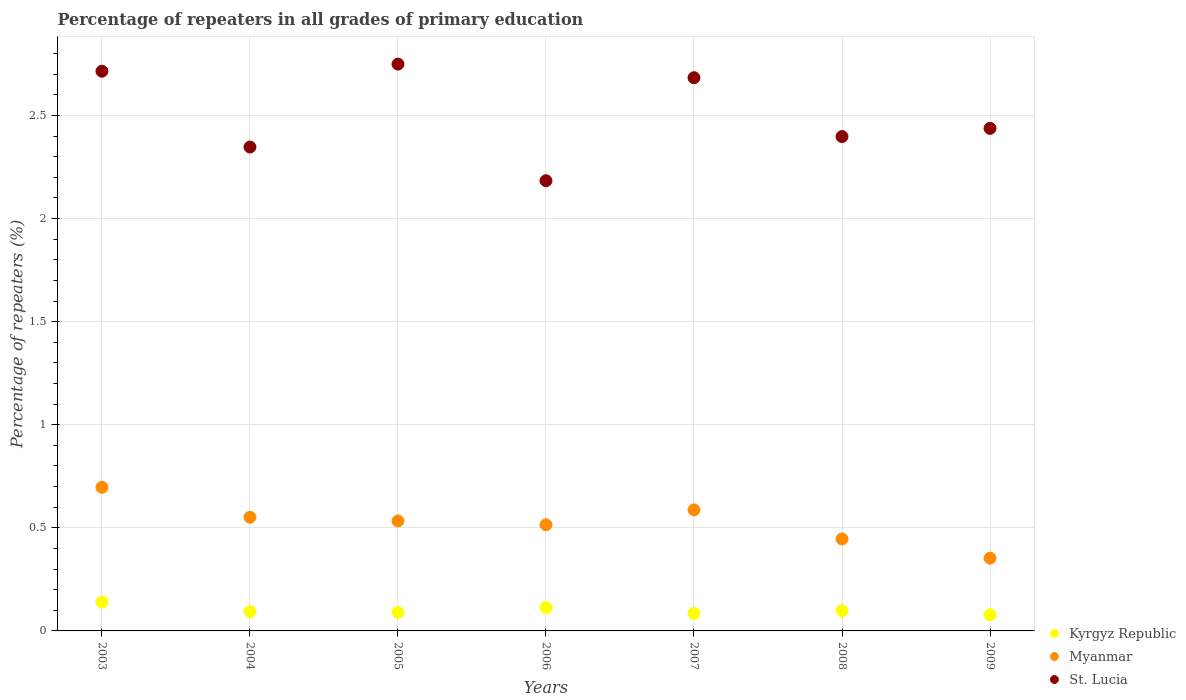What is the percentage of repeaters in St. Lucia in 2008?
Offer a very short reply. 2.4. Across all years, what is the maximum percentage of repeaters in St. Lucia?
Ensure brevity in your answer.  2.75. Across all years, what is the minimum percentage of repeaters in St. Lucia?
Offer a terse response. 2.18. In which year was the percentage of repeaters in St. Lucia maximum?
Make the answer very short. 2005. In which year was the percentage of repeaters in St. Lucia minimum?
Provide a succinct answer. 2006. What is the total percentage of repeaters in Kyrgyz Republic in the graph?
Your answer should be very brief. 0.7. What is the difference between the percentage of repeaters in St. Lucia in 2005 and that in 2006?
Your answer should be compact. 0.57. What is the difference between the percentage of repeaters in Kyrgyz Republic in 2006 and the percentage of repeaters in St. Lucia in 2009?
Give a very brief answer. -2.32. What is the average percentage of repeaters in Kyrgyz Republic per year?
Keep it short and to the point. 0.1. In the year 2008, what is the difference between the percentage of repeaters in St. Lucia and percentage of repeaters in Myanmar?
Your answer should be compact. 1.95. What is the ratio of the percentage of repeaters in St. Lucia in 2008 to that in 2009?
Your answer should be compact. 0.98. Is the percentage of repeaters in Myanmar in 2003 less than that in 2005?
Ensure brevity in your answer.  No. Is the difference between the percentage of repeaters in St. Lucia in 2004 and 2008 greater than the difference between the percentage of repeaters in Myanmar in 2004 and 2008?
Your response must be concise. No. What is the difference between the highest and the second highest percentage of repeaters in Kyrgyz Republic?
Give a very brief answer. 0.03. What is the difference between the highest and the lowest percentage of repeaters in St. Lucia?
Your answer should be very brief. 0.57. Is the sum of the percentage of repeaters in Kyrgyz Republic in 2006 and 2008 greater than the maximum percentage of repeaters in Myanmar across all years?
Your answer should be compact. No. Does the percentage of repeaters in Myanmar monotonically increase over the years?
Keep it short and to the point. No. Is the percentage of repeaters in Myanmar strictly greater than the percentage of repeaters in Kyrgyz Republic over the years?
Keep it short and to the point. Yes. How many dotlines are there?
Provide a short and direct response. 3. How many years are there in the graph?
Keep it short and to the point. 7. What is the difference between two consecutive major ticks on the Y-axis?
Keep it short and to the point. 0.5. Does the graph contain grids?
Ensure brevity in your answer.  Yes. What is the title of the graph?
Ensure brevity in your answer.  Percentage of repeaters in all grades of primary education. What is the label or title of the X-axis?
Your response must be concise. Years. What is the label or title of the Y-axis?
Keep it short and to the point. Percentage of repeaters (%). What is the Percentage of repeaters (%) of Kyrgyz Republic in 2003?
Your answer should be very brief. 0.14. What is the Percentage of repeaters (%) of Myanmar in 2003?
Offer a very short reply. 0.7. What is the Percentage of repeaters (%) of St. Lucia in 2003?
Make the answer very short. 2.71. What is the Percentage of repeaters (%) in Kyrgyz Republic in 2004?
Keep it short and to the point. 0.09. What is the Percentage of repeaters (%) in Myanmar in 2004?
Keep it short and to the point. 0.55. What is the Percentage of repeaters (%) in St. Lucia in 2004?
Offer a terse response. 2.35. What is the Percentage of repeaters (%) of Kyrgyz Republic in 2005?
Make the answer very short. 0.09. What is the Percentage of repeaters (%) of Myanmar in 2005?
Your answer should be very brief. 0.53. What is the Percentage of repeaters (%) of St. Lucia in 2005?
Ensure brevity in your answer.  2.75. What is the Percentage of repeaters (%) of Kyrgyz Republic in 2006?
Offer a terse response. 0.11. What is the Percentage of repeaters (%) of Myanmar in 2006?
Give a very brief answer. 0.51. What is the Percentage of repeaters (%) of St. Lucia in 2006?
Keep it short and to the point. 2.18. What is the Percentage of repeaters (%) in Kyrgyz Republic in 2007?
Make the answer very short. 0.08. What is the Percentage of repeaters (%) of Myanmar in 2007?
Offer a terse response. 0.59. What is the Percentage of repeaters (%) of St. Lucia in 2007?
Your answer should be compact. 2.68. What is the Percentage of repeaters (%) of Kyrgyz Republic in 2008?
Give a very brief answer. 0.1. What is the Percentage of repeaters (%) of Myanmar in 2008?
Your answer should be very brief. 0.45. What is the Percentage of repeaters (%) in St. Lucia in 2008?
Your answer should be compact. 2.4. What is the Percentage of repeaters (%) of Kyrgyz Republic in 2009?
Your answer should be very brief. 0.08. What is the Percentage of repeaters (%) of Myanmar in 2009?
Your answer should be compact. 0.35. What is the Percentage of repeaters (%) of St. Lucia in 2009?
Provide a short and direct response. 2.44. Across all years, what is the maximum Percentage of repeaters (%) of Kyrgyz Republic?
Your answer should be very brief. 0.14. Across all years, what is the maximum Percentage of repeaters (%) of Myanmar?
Make the answer very short. 0.7. Across all years, what is the maximum Percentage of repeaters (%) of St. Lucia?
Offer a terse response. 2.75. Across all years, what is the minimum Percentage of repeaters (%) of Kyrgyz Republic?
Make the answer very short. 0.08. Across all years, what is the minimum Percentage of repeaters (%) in Myanmar?
Provide a succinct answer. 0.35. Across all years, what is the minimum Percentage of repeaters (%) in St. Lucia?
Provide a short and direct response. 2.18. What is the total Percentage of repeaters (%) of Kyrgyz Republic in the graph?
Make the answer very short. 0.7. What is the total Percentage of repeaters (%) in Myanmar in the graph?
Your answer should be compact. 3.68. What is the total Percentage of repeaters (%) in St. Lucia in the graph?
Keep it short and to the point. 17.51. What is the difference between the Percentage of repeaters (%) in Kyrgyz Republic in 2003 and that in 2004?
Your answer should be very brief. 0.05. What is the difference between the Percentage of repeaters (%) in Myanmar in 2003 and that in 2004?
Your response must be concise. 0.15. What is the difference between the Percentage of repeaters (%) in St. Lucia in 2003 and that in 2004?
Your answer should be very brief. 0.37. What is the difference between the Percentage of repeaters (%) in Kyrgyz Republic in 2003 and that in 2005?
Your response must be concise. 0.05. What is the difference between the Percentage of repeaters (%) in Myanmar in 2003 and that in 2005?
Provide a short and direct response. 0.16. What is the difference between the Percentage of repeaters (%) in St. Lucia in 2003 and that in 2005?
Provide a short and direct response. -0.03. What is the difference between the Percentage of repeaters (%) in Kyrgyz Republic in 2003 and that in 2006?
Your answer should be very brief. 0.03. What is the difference between the Percentage of repeaters (%) of Myanmar in 2003 and that in 2006?
Your answer should be very brief. 0.18. What is the difference between the Percentage of repeaters (%) of St. Lucia in 2003 and that in 2006?
Offer a terse response. 0.53. What is the difference between the Percentage of repeaters (%) of Kyrgyz Republic in 2003 and that in 2007?
Offer a very short reply. 0.05. What is the difference between the Percentage of repeaters (%) of Myanmar in 2003 and that in 2007?
Your response must be concise. 0.11. What is the difference between the Percentage of repeaters (%) in St. Lucia in 2003 and that in 2007?
Your response must be concise. 0.03. What is the difference between the Percentage of repeaters (%) in Kyrgyz Republic in 2003 and that in 2008?
Give a very brief answer. 0.04. What is the difference between the Percentage of repeaters (%) of Myanmar in 2003 and that in 2008?
Make the answer very short. 0.25. What is the difference between the Percentage of repeaters (%) of St. Lucia in 2003 and that in 2008?
Provide a short and direct response. 0.32. What is the difference between the Percentage of repeaters (%) in Kyrgyz Republic in 2003 and that in 2009?
Provide a short and direct response. 0.06. What is the difference between the Percentage of repeaters (%) in Myanmar in 2003 and that in 2009?
Offer a terse response. 0.34. What is the difference between the Percentage of repeaters (%) of St. Lucia in 2003 and that in 2009?
Your answer should be very brief. 0.28. What is the difference between the Percentage of repeaters (%) of Kyrgyz Republic in 2004 and that in 2005?
Offer a very short reply. 0. What is the difference between the Percentage of repeaters (%) of Myanmar in 2004 and that in 2005?
Your response must be concise. 0.02. What is the difference between the Percentage of repeaters (%) in St. Lucia in 2004 and that in 2005?
Give a very brief answer. -0.4. What is the difference between the Percentage of repeaters (%) in Kyrgyz Republic in 2004 and that in 2006?
Your response must be concise. -0.02. What is the difference between the Percentage of repeaters (%) in Myanmar in 2004 and that in 2006?
Your answer should be very brief. 0.04. What is the difference between the Percentage of repeaters (%) of St. Lucia in 2004 and that in 2006?
Keep it short and to the point. 0.16. What is the difference between the Percentage of repeaters (%) in Kyrgyz Republic in 2004 and that in 2007?
Offer a very short reply. 0.01. What is the difference between the Percentage of repeaters (%) in Myanmar in 2004 and that in 2007?
Provide a short and direct response. -0.04. What is the difference between the Percentage of repeaters (%) of St. Lucia in 2004 and that in 2007?
Ensure brevity in your answer.  -0.34. What is the difference between the Percentage of repeaters (%) of Kyrgyz Republic in 2004 and that in 2008?
Your response must be concise. -0. What is the difference between the Percentage of repeaters (%) in Myanmar in 2004 and that in 2008?
Your answer should be compact. 0.11. What is the difference between the Percentage of repeaters (%) of St. Lucia in 2004 and that in 2008?
Ensure brevity in your answer.  -0.05. What is the difference between the Percentage of repeaters (%) in Kyrgyz Republic in 2004 and that in 2009?
Provide a succinct answer. 0.02. What is the difference between the Percentage of repeaters (%) in Myanmar in 2004 and that in 2009?
Offer a very short reply. 0.2. What is the difference between the Percentage of repeaters (%) in St. Lucia in 2004 and that in 2009?
Ensure brevity in your answer.  -0.09. What is the difference between the Percentage of repeaters (%) of Kyrgyz Republic in 2005 and that in 2006?
Your response must be concise. -0.02. What is the difference between the Percentage of repeaters (%) in Myanmar in 2005 and that in 2006?
Give a very brief answer. 0.02. What is the difference between the Percentage of repeaters (%) of St. Lucia in 2005 and that in 2006?
Your response must be concise. 0.57. What is the difference between the Percentage of repeaters (%) in Kyrgyz Republic in 2005 and that in 2007?
Provide a short and direct response. 0.01. What is the difference between the Percentage of repeaters (%) in Myanmar in 2005 and that in 2007?
Give a very brief answer. -0.05. What is the difference between the Percentage of repeaters (%) in St. Lucia in 2005 and that in 2007?
Provide a short and direct response. 0.07. What is the difference between the Percentage of repeaters (%) of Kyrgyz Republic in 2005 and that in 2008?
Provide a succinct answer. -0.01. What is the difference between the Percentage of repeaters (%) in Myanmar in 2005 and that in 2008?
Give a very brief answer. 0.09. What is the difference between the Percentage of repeaters (%) in St. Lucia in 2005 and that in 2008?
Provide a succinct answer. 0.35. What is the difference between the Percentage of repeaters (%) in Kyrgyz Republic in 2005 and that in 2009?
Your answer should be compact. 0.01. What is the difference between the Percentage of repeaters (%) of Myanmar in 2005 and that in 2009?
Keep it short and to the point. 0.18. What is the difference between the Percentage of repeaters (%) of St. Lucia in 2005 and that in 2009?
Offer a terse response. 0.31. What is the difference between the Percentage of repeaters (%) in Kyrgyz Republic in 2006 and that in 2007?
Provide a succinct answer. 0.03. What is the difference between the Percentage of repeaters (%) of Myanmar in 2006 and that in 2007?
Give a very brief answer. -0.07. What is the difference between the Percentage of repeaters (%) of St. Lucia in 2006 and that in 2007?
Give a very brief answer. -0.5. What is the difference between the Percentage of repeaters (%) in Kyrgyz Republic in 2006 and that in 2008?
Your answer should be compact. 0.02. What is the difference between the Percentage of repeaters (%) in Myanmar in 2006 and that in 2008?
Keep it short and to the point. 0.07. What is the difference between the Percentage of repeaters (%) of St. Lucia in 2006 and that in 2008?
Keep it short and to the point. -0.21. What is the difference between the Percentage of repeaters (%) of Kyrgyz Republic in 2006 and that in 2009?
Offer a very short reply. 0.03. What is the difference between the Percentage of repeaters (%) of Myanmar in 2006 and that in 2009?
Offer a terse response. 0.16. What is the difference between the Percentage of repeaters (%) in St. Lucia in 2006 and that in 2009?
Make the answer very short. -0.25. What is the difference between the Percentage of repeaters (%) in Kyrgyz Republic in 2007 and that in 2008?
Provide a succinct answer. -0.01. What is the difference between the Percentage of repeaters (%) of Myanmar in 2007 and that in 2008?
Your answer should be compact. 0.14. What is the difference between the Percentage of repeaters (%) of St. Lucia in 2007 and that in 2008?
Ensure brevity in your answer.  0.29. What is the difference between the Percentage of repeaters (%) in Kyrgyz Republic in 2007 and that in 2009?
Your answer should be very brief. 0.01. What is the difference between the Percentage of repeaters (%) in Myanmar in 2007 and that in 2009?
Offer a terse response. 0.23. What is the difference between the Percentage of repeaters (%) of St. Lucia in 2007 and that in 2009?
Provide a short and direct response. 0.25. What is the difference between the Percentage of repeaters (%) of Kyrgyz Republic in 2008 and that in 2009?
Offer a terse response. 0.02. What is the difference between the Percentage of repeaters (%) of Myanmar in 2008 and that in 2009?
Offer a very short reply. 0.09. What is the difference between the Percentage of repeaters (%) of St. Lucia in 2008 and that in 2009?
Provide a short and direct response. -0.04. What is the difference between the Percentage of repeaters (%) in Kyrgyz Republic in 2003 and the Percentage of repeaters (%) in Myanmar in 2004?
Give a very brief answer. -0.41. What is the difference between the Percentage of repeaters (%) in Kyrgyz Republic in 2003 and the Percentage of repeaters (%) in St. Lucia in 2004?
Provide a succinct answer. -2.21. What is the difference between the Percentage of repeaters (%) of Myanmar in 2003 and the Percentage of repeaters (%) of St. Lucia in 2004?
Offer a terse response. -1.65. What is the difference between the Percentage of repeaters (%) in Kyrgyz Republic in 2003 and the Percentage of repeaters (%) in Myanmar in 2005?
Your answer should be very brief. -0.39. What is the difference between the Percentage of repeaters (%) of Kyrgyz Republic in 2003 and the Percentage of repeaters (%) of St. Lucia in 2005?
Your answer should be compact. -2.61. What is the difference between the Percentage of repeaters (%) in Myanmar in 2003 and the Percentage of repeaters (%) in St. Lucia in 2005?
Keep it short and to the point. -2.05. What is the difference between the Percentage of repeaters (%) of Kyrgyz Republic in 2003 and the Percentage of repeaters (%) of Myanmar in 2006?
Provide a succinct answer. -0.38. What is the difference between the Percentage of repeaters (%) of Kyrgyz Republic in 2003 and the Percentage of repeaters (%) of St. Lucia in 2006?
Provide a succinct answer. -2.04. What is the difference between the Percentage of repeaters (%) of Myanmar in 2003 and the Percentage of repeaters (%) of St. Lucia in 2006?
Give a very brief answer. -1.49. What is the difference between the Percentage of repeaters (%) in Kyrgyz Republic in 2003 and the Percentage of repeaters (%) in Myanmar in 2007?
Make the answer very short. -0.45. What is the difference between the Percentage of repeaters (%) in Kyrgyz Republic in 2003 and the Percentage of repeaters (%) in St. Lucia in 2007?
Offer a very short reply. -2.54. What is the difference between the Percentage of repeaters (%) of Myanmar in 2003 and the Percentage of repeaters (%) of St. Lucia in 2007?
Give a very brief answer. -1.99. What is the difference between the Percentage of repeaters (%) in Kyrgyz Republic in 2003 and the Percentage of repeaters (%) in Myanmar in 2008?
Keep it short and to the point. -0.31. What is the difference between the Percentage of repeaters (%) of Kyrgyz Republic in 2003 and the Percentage of repeaters (%) of St. Lucia in 2008?
Make the answer very short. -2.26. What is the difference between the Percentage of repeaters (%) of Myanmar in 2003 and the Percentage of repeaters (%) of St. Lucia in 2008?
Provide a short and direct response. -1.7. What is the difference between the Percentage of repeaters (%) of Kyrgyz Republic in 2003 and the Percentage of repeaters (%) of Myanmar in 2009?
Provide a succinct answer. -0.21. What is the difference between the Percentage of repeaters (%) of Kyrgyz Republic in 2003 and the Percentage of repeaters (%) of St. Lucia in 2009?
Your answer should be compact. -2.3. What is the difference between the Percentage of repeaters (%) of Myanmar in 2003 and the Percentage of repeaters (%) of St. Lucia in 2009?
Your response must be concise. -1.74. What is the difference between the Percentage of repeaters (%) of Kyrgyz Republic in 2004 and the Percentage of repeaters (%) of Myanmar in 2005?
Make the answer very short. -0.44. What is the difference between the Percentage of repeaters (%) of Kyrgyz Republic in 2004 and the Percentage of repeaters (%) of St. Lucia in 2005?
Offer a terse response. -2.66. What is the difference between the Percentage of repeaters (%) in Myanmar in 2004 and the Percentage of repeaters (%) in St. Lucia in 2005?
Provide a succinct answer. -2.2. What is the difference between the Percentage of repeaters (%) of Kyrgyz Republic in 2004 and the Percentage of repeaters (%) of Myanmar in 2006?
Make the answer very short. -0.42. What is the difference between the Percentage of repeaters (%) in Kyrgyz Republic in 2004 and the Percentage of repeaters (%) in St. Lucia in 2006?
Keep it short and to the point. -2.09. What is the difference between the Percentage of repeaters (%) of Myanmar in 2004 and the Percentage of repeaters (%) of St. Lucia in 2006?
Keep it short and to the point. -1.63. What is the difference between the Percentage of repeaters (%) of Kyrgyz Republic in 2004 and the Percentage of repeaters (%) of Myanmar in 2007?
Make the answer very short. -0.49. What is the difference between the Percentage of repeaters (%) in Kyrgyz Republic in 2004 and the Percentage of repeaters (%) in St. Lucia in 2007?
Provide a succinct answer. -2.59. What is the difference between the Percentage of repeaters (%) in Myanmar in 2004 and the Percentage of repeaters (%) in St. Lucia in 2007?
Your answer should be compact. -2.13. What is the difference between the Percentage of repeaters (%) of Kyrgyz Republic in 2004 and the Percentage of repeaters (%) of Myanmar in 2008?
Give a very brief answer. -0.35. What is the difference between the Percentage of repeaters (%) in Kyrgyz Republic in 2004 and the Percentage of repeaters (%) in St. Lucia in 2008?
Your answer should be very brief. -2.3. What is the difference between the Percentage of repeaters (%) of Myanmar in 2004 and the Percentage of repeaters (%) of St. Lucia in 2008?
Keep it short and to the point. -1.85. What is the difference between the Percentage of repeaters (%) in Kyrgyz Republic in 2004 and the Percentage of repeaters (%) in Myanmar in 2009?
Make the answer very short. -0.26. What is the difference between the Percentage of repeaters (%) in Kyrgyz Republic in 2004 and the Percentage of repeaters (%) in St. Lucia in 2009?
Provide a succinct answer. -2.34. What is the difference between the Percentage of repeaters (%) in Myanmar in 2004 and the Percentage of repeaters (%) in St. Lucia in 2009?
Offer a very short reply. -1.89. What is the difference between the Percentage of repeaters (%) of Kyrgyz Republic in 2005 and the Percentage of repeaters (%) of Myanmar in 2006?
Your answer should be compact. -0.43. What is the difference between the Percentage of repeaters (%) in Kyrgyz Republic in 2005 and the Percentage of repeaters (%) in St. Lucia in 2006?
Keep it short and to the point. -2.09. What is the difference between the Percentage of repeaters (%) of Myanmar in 2005 and the Percentage of repeaters (%) of St. Lucia in 2006?
Make the answer very short. -1.65. What is the difference between the Percentage of repeaters (%) of Kyrgyz Republic in 2005 and the Percentage of repeaters (%) of Myanmar in 2007?
Your answer should be compact. -0.5. What is the difference between the Percentage of repeaters (%) of Kyrgyz Republic in 2005 and the Percentage of repeaters (%) of St. Lucia in 2007?
Ensure brevity in your answer.  -2.59. What is the difference between the Percentage of repeaters (%) in Myanmar in 2005 and the Percentage of repeaters (%) in St. Lucia in 2007?
Make the answer very short. -2.15. What is the difference between the Percentage of repeaters (%) in Kyrgyz Republic in 2005 and the Percentage of repeaters (%) in Myanmar in 2008?
Your response must be concise. -0.36. What is the difference between the Percentage of repeaters (%) of Kyrgyz Republic in 2005 and the Percentage of repeaters (%) of St. Lucia in 2008?
Offer a terse response. -2.31. What is the difference between the Percentage of repeaters (%) in Myanmar in 2005 and the Percentage of repeaters (%) in St. Lucia in 2008?
Provide a succinct answer. -1.86. What is the difference between the Percentage of repeaters (%) in Kyrgyz Republic in 2005 and the Percentage of repeaters (%) in Myanmar in 2009?
Make the answer very short. -0.26. What is the difference between the Percentage of repeaters (%) of Kyrgyz Republic in 2005 and the Percentage of repeaters (%) of St. Lucia in 2009?
Your answer should be very brief. -2.35. What is the difference between the Percentage of repeaters (%) of Myanmar in 2005 and the Percentage of repeaters (%) of St. Lucia in 2009?
Provide a succinct answer. -1.9. What is the difference between the Percentage of repeaters (%) of Kyrgyz Republic in 2006 and the Percentage of repeaters (%) of Myanmar in 2007?
Your answer should be very brief. -0.47. What is the difference between the Percentage of repeaters (%) in Kyrgyz Republic in 2006 and the Percentage of repeaters (%) in St. Lucia in 2007?
Provide a short and direct response. -2.57. What is the difference between the Percentage of repeaters (%) in Myanmar in 2006 and the Percentage of repeaters (%) in St. Lucia in 2007?
Provide a succinct answer. -2.17. What is the difference between the Percentage of repeaters (%) of Kyrgyz Republic in 2006 and the Percentage of repeaters (%) of Myanmar in 2008?
Provide a succinct answer. -0.33. What is the difference between the Percentage of repeaters (%) in Kyrgyz Republic in 2006 and the Percentage of repeaters (%) in St. Lucia in 2008?
Provide a short and direct response. -2.28. What is the difference between the Percentage of repeaters (%) in Myanmar in 2006 and the Percentage of repeaters (%) in St. Lucia in 2008?
Keep it short and to the point. -1.88. What is the difference between the Percentage of repeaters (%) in Kyrgyz Republic in 2006 and the Percentage of repeaters (%) in Myanmar in 2009?
Ensure brevity in your answer.  -0.24. What is the difference between the Percentage of repeaters (%) of Kyrgyz Republic in 2006 and the Percentage of repeaters (%) of St. Lucia in 2009?
Your answer should be very brief. -2.32. What is the difference between the Percentage of repeaters (%) in Myanmar in 2006 and the Percentage of repeaters (%) in St. Lucia in 2009?
Give a very brief answer. -1.92. What is the difference between the Percentage of repeaters (%) in Kyrgyz Republic in 2007 and the Percentage of repeaters (%) in Myanmar in 2008?
Provide a short and direct response. -0.36. What is the difference between the Percentage of repeaters (%) of Kyrgyz Republic in 2007 and the Percentage of repeaters (%) of St. Lucia in 2008?
Ensure brevity in your answer.  -2.31. What is the difference between the Percentage of repeaters (%) in Myanmar in 2007 and the Percentage of repeaters (%) in St. Lucia in 2008?
Provide a succinct answer. -1.81. What is the difference between the Percentage of repeaters (%) of Kyrgyz Republic in 2007 and the Percentage of repeaters (%) of Myanmar in 2009?
Keep it short and to the point. -0.27. What is the difference between the Percentage of repeaters (%) in Kyrgyz Republic in 2007 and the Percentage of repeaters (%) in St. Lucia in 2009?
Make the answer very short. -2.35. What is the difference between the Percentage of repeaters (%) in Myanmar in 2007 and the Percentage of repeaters (%) in St. Lucia in 2009?
Your response must be concise. -1.85. What is the difference between the Percentage of repeaters (%) in Kyrgyz Republic in 2008 and the Percentage of repeaters (%) in Myanmar in 2009?
Your answer should be compact. -0.26. What is the difference between the Percentage of repeaters (%) of Kyrgyz Republic in 2008 and the Percentage of repeaters (%) of St. Lucia in 2009?
Give a very brief answer. -2.34. What is the difference between the Percentage of repeaters (%) in Myanmar in 2008 and the Percentage of repeaters (%) in St. Lucia in 2009?
Your response must be concise. -1.99. What is the average Percentage of repeaters (%) in Kyrgyz Republic per year?
Provide a short and direct response. 0.1. What is the average Percentage of repeaters (%) of Myanmar per year?
Provide a short and direct response. 0.53. What is the average Percentage of repeaters (%) of St. Lucia per year?
Your answer should be compact. 2.5. In the year 2003, what is the difference between the Percentage of repeaters (%) of Kyrgyz Republic and Percentage of repeaters (%) of Myanmar?
Keep it short and to the point. -0.56. In the year 2003, what is the difference between the Percentage of repeaters (%) in Kyrgyz Republic and Percentage of repeaters (%) in St. Lucia?
Your answer should be compact. -2.57. In the year 2003, what is the difference between the Percentage of repeaters (%) in Myanmar and Percentage of repeaters (%) in St. Lucia?
Provide a short and direct response. -2.02. In the year 2004, what is the difference between the Percentage of repeaters (%) in Kyrgyz Republic and Percentage of repeaters (%) in Myanmar?
Offer a terse response. -0.46. In the year 2004, what is the difference between the Percentage of repeaters (%) of Kyrgyz Republic and Percentage of repeaters (%) of St. Lucia?
Give a very brief answer. -2.25. In the year 2004, what is the difference between the Percentage of repeaters (%) of Myanmar and Percentage of repeaters (%) of St. Lucia?
Your answer should be very brief. -1.8. In the year 2005, what is the difference between the Percentage of repeaters (%) of Kyrgyz Republic and Percentage of repeaters (%) of Myanmar?
Your response must be concise. -0.44. In the year 2005, what is the difference between the Percentage of repeaters (%) of Kyrgyz Republic and Percentage of repeaters (%) of St. Lucia?
Your answer should be very brief. -2.66. In the year 2005, what is the difference between the Percentage of repeaters (%) of Myanmar and Percentage of repeaters (%) of St. Lucia?
Offer a terse response. -2.22. In the year 2006, what is the difference between the Percentage of repeaters (%) in Kyrgyz Republic and Percentage of repeaters (%) in Myanmar?
Your answer should be very brief. -0.4. In the year 2006, what is the difference between the Percentage of repeaters (%) in Kyrgyz Republic and Percentage of repeaters (%) in St. Lucia?
Provide a short and direct response. -2.07. In the year 2006, what is the difference between the Percentage of repeaters (%) in Myanmar and Percentage of repeaters (%) in St. Lucia?
Make the answer very short. -1.67. In the year 2007, what is the difference between the Percentage of repeaters (%) in Kyrgyz Republic and Percentage of repeaters (%) in Myanmar?
Your response must be concise. -0.5. In the year 2007, what is the difference between the Percentage of repeaters (%) in Kyrgyz Republic and Percentage of repeaters (%) in St. Lucia?
Provide a short and direct response. -2.6. In the year 2007, what is the difference between the Percentage of repeaters (%) in Myanmar and Percentage of repeaters (%) in St. Lucia?
Offer a very short reply. -2.1. In the year 2008, what is the difference between the Percentage of repeaters (%) of Kyrgyz Republic and Percentage of repeaters (%) of Myanmar?
Provide a succinct answer. -0.35. In the year 2008, what is the difference between the Percentage of repeaters (%) of Myanmar and Percentage of repeaters (%) of St. Lucia?
Offer a very short reply. -1.95. In the year 2009, what is the difference between the Percentage of repeaters (%) of Kyrgyz Republic and Percentage of repeaters (%) of Myanmar?
Offer a terse response. -0.27. In the year 2009, what is the difference between the Percentage of repeaters (%) of Kyrgyz Republic and Percentage of repeaters (%) of St. Lucia?
Your response must be concise. -2.36. In the year 2009, what is the difference between the Percentage of repeaters (%) in Myanmar and Percentage of repeaters (%) in St. Lucia?
Make the answer very short. -2.08. What is the ratio of the Percentage of repeaters (%) in Kyrgyz Republic in 2003 to that in 2004?
Ensure brevity in your answer.  1.49. What is the ratio of the Percentage of repeaters (%) of Myanmar in 2003 to that in 2004?
Your answer should be very brief. 1.26. What is the ratio of the Percentage of repeaters (%) of St. Lucia in 2003 to that in 2004?
Provide a short and direct response. 1.16. What is the ratio of the Percentage of repeaters (%) in Kyrgyz Republic in 2003 to that in 2005?
Provide a succinct answer. 1.56. What is the ratio of the Percentage of repeaters (%) of Myanmar in 2003 to that in 2005?
Offer a very short reply. 1.31. What is the ratio of the Percentage of repeaters (%) in St. Lucia in 2003 to that in 2005?
Provide a succinct answer. 0.99. What is the ratio of the Percentage of repeaters (%) of Kyrgyz Republic in 2003 to that in 2006?
Your answer should be very brief. 1.24. What is the ratio of the Percentage of repeaters (%) in Myanmar in 2003 to that in 2006?
Ensure brevity in your answer.  1.35. What is the ratio of the Percentage of repeaters (%) in St. Lucia in 2003 to that in 2006?
Offer a very short reply. 1.24. What is the ratio of the Percentage of repeaters (%) of Kyrgyz Republic in 2003 to that in 2007?
Your answer should be compact. 1.65. What is the ratio of the Percentage of repeaters (%) in Myanmar in 2003 to that in 2007?
Ensure brevity in your answer.  1.19. What is the ratio of the Percentage of repeaters (%) of St. Lucia in 2003 to that in 2007?
Offer a very short reply. 1.01. What is the ratio of the Percentage of repeaters (%) of Kyrgyz Republic in 2003 to that in 2008?
Your response must be concise. 1.43. What is the ratio of the Percentage of repeaters (%) in Myanmar in 2003 to that in 2008?
Offer a terse response. 1.56. What is the ratio of the Percentage of repeaters (%) in St. Lucia in 2003 to that in 2008?
Offer a very short reply. 1.13. What is the ratio of the Percentage of repeaters (%) in Kyrgyz Republic in 2003 to that in 2009?
Your answer should be very brief. 1.78. What is the ratio of the Percentage of repeaters (%) of Myanmar in 2003 to that in 2009?
Your answer should be very brief. 1.98. What is the ratio of the Percentage of repeaters (%) of St. Lucia in 2003 to that in 2009?
Offer a very short reply. 1.11. What is the ratio of the Percentage of repeaters (%) in Kyrgyz Republic in 2004 to that in 2005?
Provide a succinct answer. 1.04. What is the ratio of the Percentage of repeaters (%) of Myanmar in 2004 to that in 2005?
Ensure brevity in your answer.  1.03. What is the ratio of the Percentage of repeaters (%) of St. Lucia in 2004 to that in 2005?
Your answer should be compact. 0.85. What is the ratio of the Percentage of repeaters (%) in Kyrgyz Republic in 2004 to that in 2006?
Your answer should be very brief. 0.83. What is the ratio of the Percentage of repeaters (%) of Myanmar in 2004 to that in 2006?
Offer a terse response. 1.07. What is the ratio of the Percentage of repeaters (%) of St. Lucia in 2004 to that in 2006?
Provide a succinct answer. 1.07. What is the ratio of the Percentage of repeaters (%) of Kyrgyz Republic in 2004 to that in 2007?
Your answer should be compact. 1.1. What is the ratio of the Percentage of repeaters (%) in Myanmar in 2004 to that in 2007?
Offer a terse response. 0.94. What is the ratio of the Percentage of repeaters (%) in St. Lucia in 2004 to that in 2007?
Keep it short and to the point. 0.87. What is the ratio of the Percentage of repeaters (%) of Kyrgyz Republic in 2004 to that in 2008?
Make the answer very short. 0.96. What is the ratio of the Percentage of repeaters (%) of Myanmar in 2004 to that in 2008?
Provide a succinct answer. 1.24. What is the ratio of the Percentage of repeaters (%) of St. Lucia in 2004 to that in 2008?
Give a very brief answer. 0.98. What is the ratio of the Percentage of repeaters (%) of Kyrgyz Republic in 2004 to that in 2009?
Provide a succinct answer. 1.19. What is the ratio of the Percentage of repeaters (%) of Myanmar in 2004 to that in 2009?
Make the answer very short. 1.56. What is the ratio of the Percentage of repeaters (%) in St. Lucia in 2004 to that in 2009?
Provide a succinct answer. 0.96. What is the ratio of the Percentage of repeaters (%) of Kyrgyz Republic in 2005 to that in 2006?
Your response must be concise. 0.8. What is the ratio of the Percentage of repeaters (%) of Myanmar in 2005 to that in 2006?
Give a very brief answer. 1.04. What is the ratio of the Percentage of repeaters (%) of St. Lucia in 2005 to that in 2006?
Keep it short and to the point. 1.26. What is the ratio of the Percentage of repeaters (%) in Kyrgyz Republic in 2005 to that in 2007?
Your answer should be very brief. 1.06. What is the ratio of the Percentage of repeaters (%) in Myanmar in 2005 to that in 2007?
Provide a short and direct response. 0.91. What is the ratio of the Percentage of repeaters (%) of St. Lucia in 2005 to that in 2007?
Provide a short and direct response. 1.02. What is the ratio of the Percentage of repeaters (%) of Kyrgyz Republic in 2005 to that in 2008?
Offer a very short reply. 0.92. What is the ratio of the Percentage of repeaters (%) in Myanmar in 2005 to that in 2008?
Your answer should be very brief. 1.2. What is the ratio of the Percentage of repeaters (%) in St. Lucia in 2005 to that in 2008?
Make the answer very short. 1.15. What is the ratio of the Percentage of repeaters (%) of Kyrgyz Republic in 2005 to that in 2009?
Ensure brevity in your answer.  1.14. What is the ratio of the Percentage of repeaters (%) in Myanmar in 2005 to that in 2009?
Offer a terse response. 1.51. What is the ratio of the Percentage of repeaters (%) in St. Lucia in 2005 to that in 2009?
Offer a terse response. 1.13. What is the ratio of the Percentage of repeaters (%) of Kyrgyz Republic in 2006 to that in 2007?
Provide a short and direct response. 1.33. What is the ratio of the Percentage of repeaters (%) in Myanmar in 2006 to that in 2007?
Make the answer very short. 0.88. What is the ratio of the Percentage of repeaters (%) in St. Lucia in 2006 to that in 2007?
Your answer should be compact. 0.81. What is the ratio of the Percentage of repeaters (%) of Kyrgyz Republic in 2006 to that in 2008?
Keep it short and to the point. 1.16. What is the ratio of the Percentage of repeaters (%) in Myanmar in 2006 to that in 2008?
Offer a terse response. 1.15. What is the ratio of the Percentage of repeaters (%) of St. Lucia in 2006 to that in 2008?
Your response must be concise. 0.91. What is the ratio of the Percentage of repeaters (%) of Kyrgyz Republic in 2006 to that in 2009?
Ensure brevity in your answer.  1.44. What is the ratio of the Percentage of repeaters (%) in Myanmar in 2006 to that in 2009?
Your answer should be compact. 1.46. What is the ratio of the Percentage of repeaters (%) in St. Lucia in 2006 to that in 2009?
Your answer should be compact. 0.9. What is the ratio of the Percentage of repeaters (%) in Kyrgyz Republic in 2007 to that in 2008?
Your response must be concise. 0.87. What is the ratio of the Percentage of repeaters (%) of Myanmar in 2007 to that in 2008?
Ensure brevity in your answer.  1.32. What is the ratio of the Percentage of repeaters (%) in St. Lucia in 2007 to that in 2008?
Offer a very short reply. 1.12. What is the ratio of the Percentage of repeaters (%) of Kyrgyz Republic in 2007 to that in 2009?
Give a very brief answer. 1.08. What is the ratio of the Percentage of repeaters (%) in Myanmar in 2007 to that in 2009?
Your answer should be very brief. 1.66. What is the ratio of the Percentage of repeaters (%) in St. Lucia in 2007 to that in 2009?
Your answer should be very brief. 1.1. What is the ratio of the Percentage of repeaters (%) in Kyrgyz Republic in 2008 to that in 2009?
Offer a terse response. 1.24. What is the ratio of the Percentage of repeaters (%) of Myanmar in 2008 to that in 2009?
Your answer should be compact. 1.26. What is the ratio of the Percentage of repeaters (%) in St. Lucia in 2008 to that in 2009?
Your response must be concise. 0.98. What is the difference between the highest and the second highest Percentage of repeaters (%) of Kyrgyz Republic?
Offer a terse response. 0.03. What is the difference between the highest and the second highest Percentage of repeaters (%) of Myanmar?
Give a very brief answer. 0.11. What is the difference between the highest and the second highest Percentage of repeaters (%) of St. Lucia?
Ensure brevity in your answer.  0.03. What is the difference between the highest and the lowest Percentage of repeaters (%) of Kyrgyz Republic?
Keep it short and to the point. 0.06. What is the difference between the highest and the lowest Percentage of repeaters (%) of Myanmar?
Your answer should be compact. 0.34. What is the difference between the highest and the lowest Percentage of repeaters (%) of St. Lucia?
Make the answer very short. 0.57. 